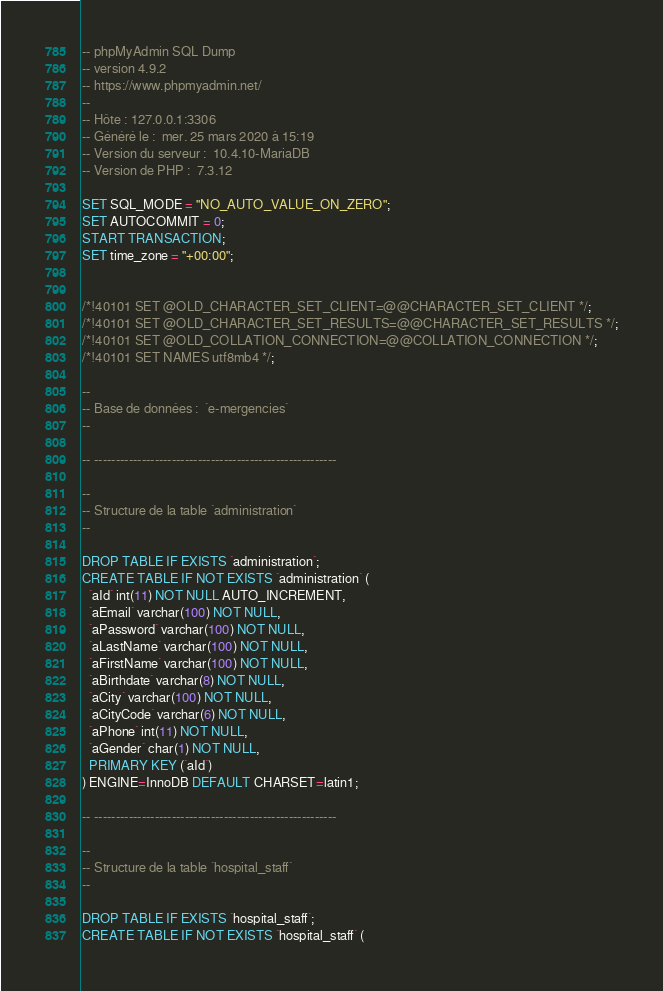<code> <loc_0><loc_0><loc_500><loc_500><_SQL_>-- phpMyAdmin SQL Dump
-- version 4.9.2
-- https://www.phpmyadmin.net/
--
-- Hôte : 127.0.0.1:3306
-- Généré le :  mer. 25 mars 2020 à 15:19
-- Version du serveur :  10.4.10-MariaDB
-- Version de PHP :  7.3.12

SET SQL_MODE = "NO_AUTO_VALUE_ON_ZERO";
SET AUTOCOMMIT = 0;
START TRANSACTION;
SET time_zone = "+00:00";


/*!40101 SET @OLD_CHARACTER_SET_CLIENT=@@CHARACTER_SET_CLIENT */;
/*!40101 SET @OLD_CHARACTER_SET_RESULTS=@@CHARACTER_SET_RESULTS */;
/*!40101 SET @OLD_COLLATION_CONNECTION=@@COLLATION_CONNECTION */;
/*!40101 SET NAMES utf8mb4 */;

--
-- Base de données :  `e-mergencies`
--

-- --------------------------------------------------------

--
-- Structure de la table `administration`
--

DROP TABLE IF EXISTS `administration`;
CREATE TABLE IF NOT EXISTS `administration` (
  `aId` int(11) NOT NULL AUTO_INCREMENT,
  `aEmail` varchar(100) NOT NULL,
  `aPassword` varchar(100) NOT NULL,
  `aLastName` varchar(100) NOT NULL,
  `aFirstName` varchar(100) NOT NULL,
  `aBirthdate` varchar(8) NOT NULL,
  `aCity` varchar(100) NOT NULL,
  `aCityCode` varchar(6) NOT NULL,
  `aPhone` int(11) NOT NULL,
  `aGender` char(1) NOT NULL,
  PRIMARY KEY (`aId`)
) ENGINE=InnoDB DEFAULT CHARSET=latin1;

-- --------------------------------------------------------

--
-- Structure de la table `hospital_staff`
--

DROP TABLE IF EXISTS `hospital_staff`;
CREATE TABLE IF NOT EXISTS `hospital_staff` (</code> 